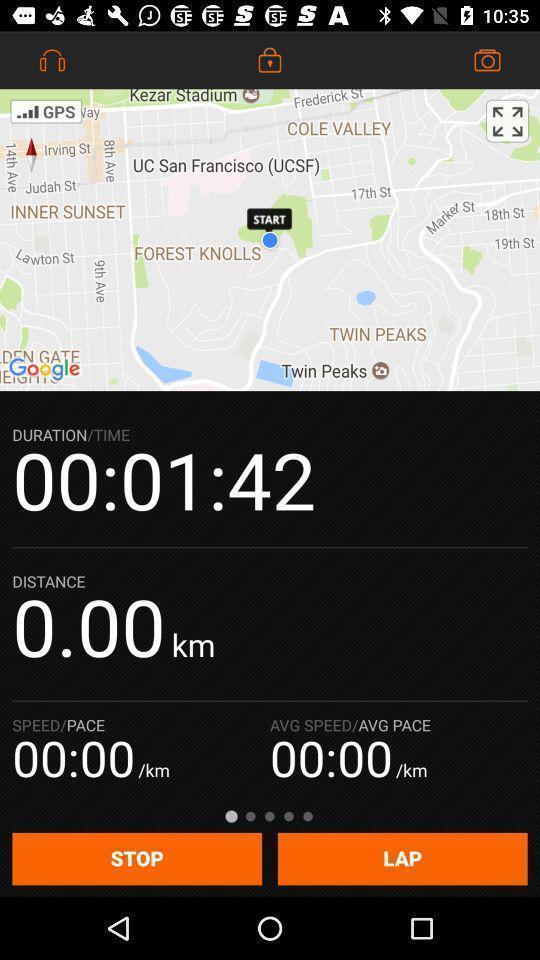Describe the key features of this screenshot. Screen displaying the stop watch timer. 